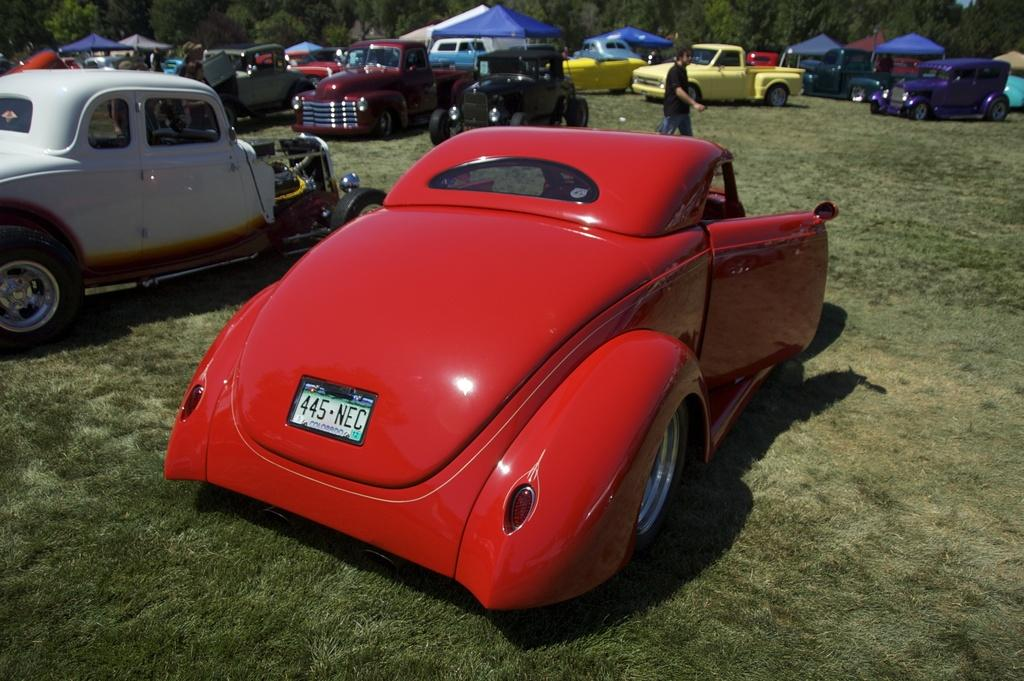What types of objects can be seen in the image? There are vehicles in the image. Where are the vehicles located in the image? There are vehicles in the background of the image. What else can be seen in the background of the image? There are stalls, a person, trees, and other objects in the background of the image. What is at the bottom of the image? There is grass at the bottom of the image. How many stems can be seen in the image? There is no mention of stems in the image; the focus is on vehicles, stalls, a person, trees, and other objects in the background, as well as grass at the bottom of the image. 